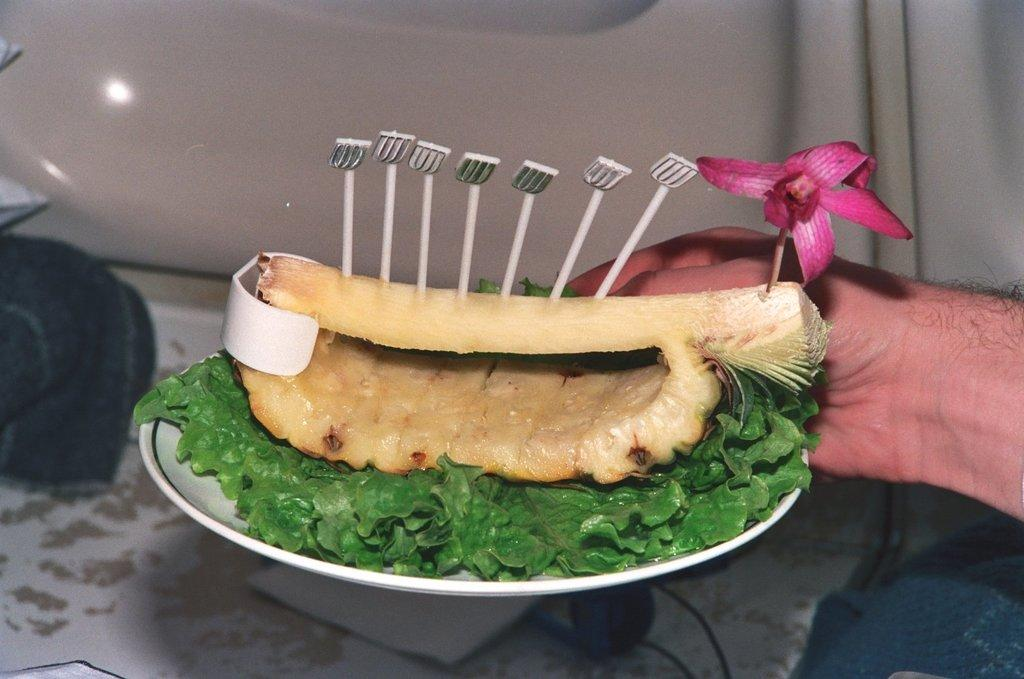What type of items can be seen in the image? There is food and a flower in the image. How are the food and flower arranged in the image? The food and flower are in a plate. Can you describe any other elements in the image? A human hand is visible in the image. How many knots are tied in the wool in the image? There is no wool or knots present in the image. 